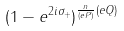Convert formula to latex. <formula><loc_0><loc_0><loc_500><loc_500>( 1 - e ^ { 2 i \sigma _ { + } } ) ^ { \frac { n } { ( e P ) } ( e Q ) }</formula> 